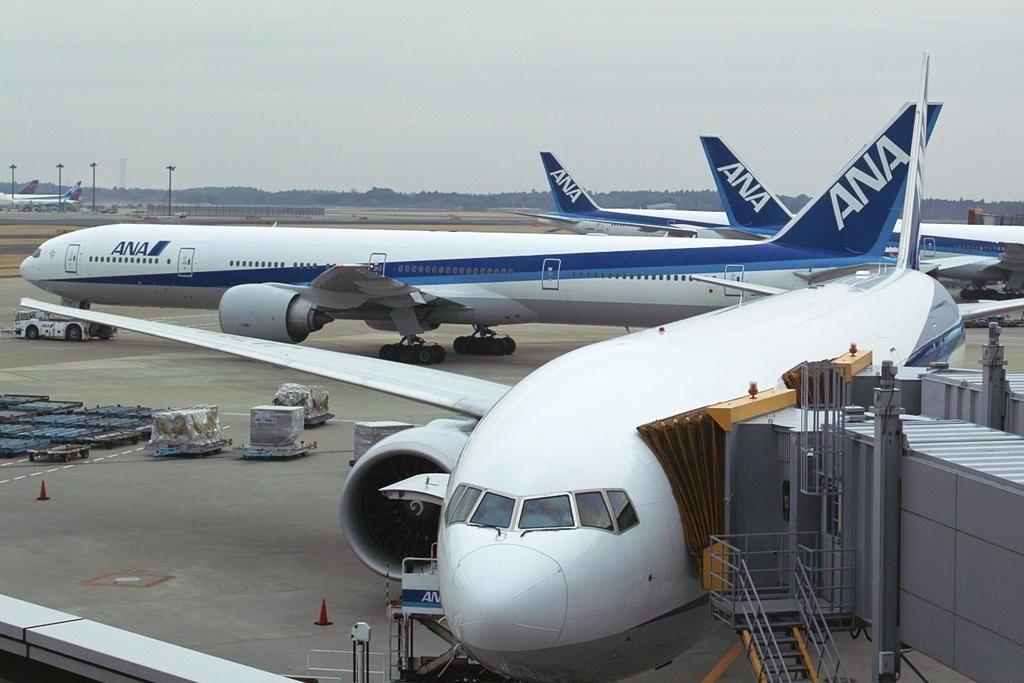Please provide a concise description of this image. In this image I can see many aircrafts. To the right I can see the stairs, railing and the grey color object. To the left I can see many trolleys and few objects on the trolleys. In the background I can see many poles, railing, trees and the sky. 